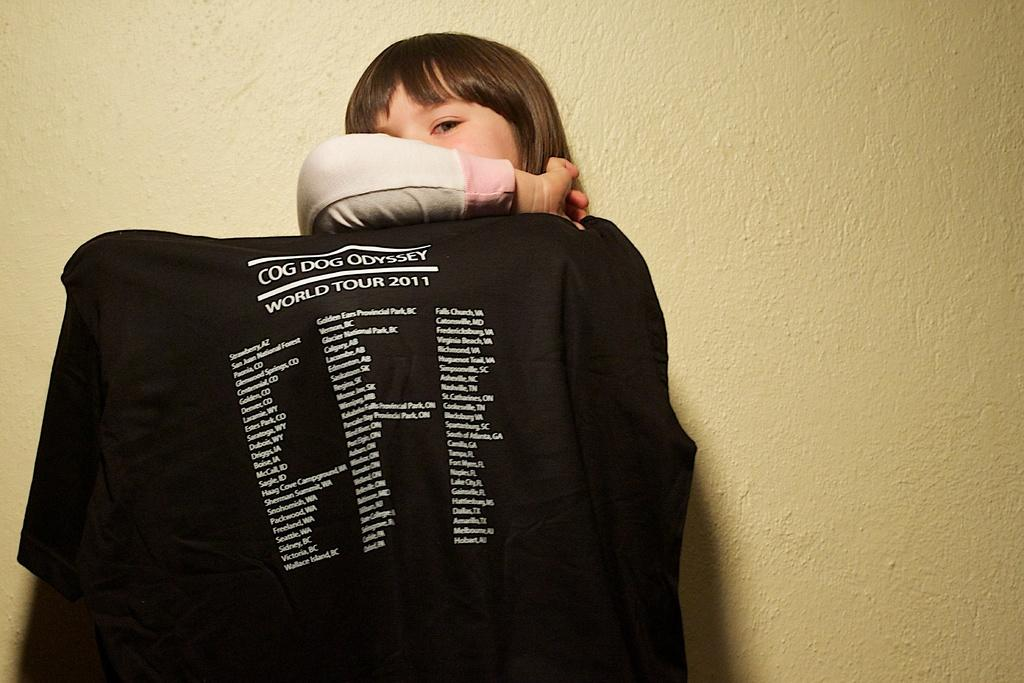Who is the main subject in the image? There is a girl in the image. Where is the girl positioned in relation to the wall? The girl is standing near a wall. What is the girl doing with her hand? The girl is covering her face with a hand. What can be seen on the black cloth in the image? The black cloth has some information on it. Who is the owner of the girl in the image? There is no indication in the image that the girl has an owner, and the concept of ownership is not applicable in this context. 